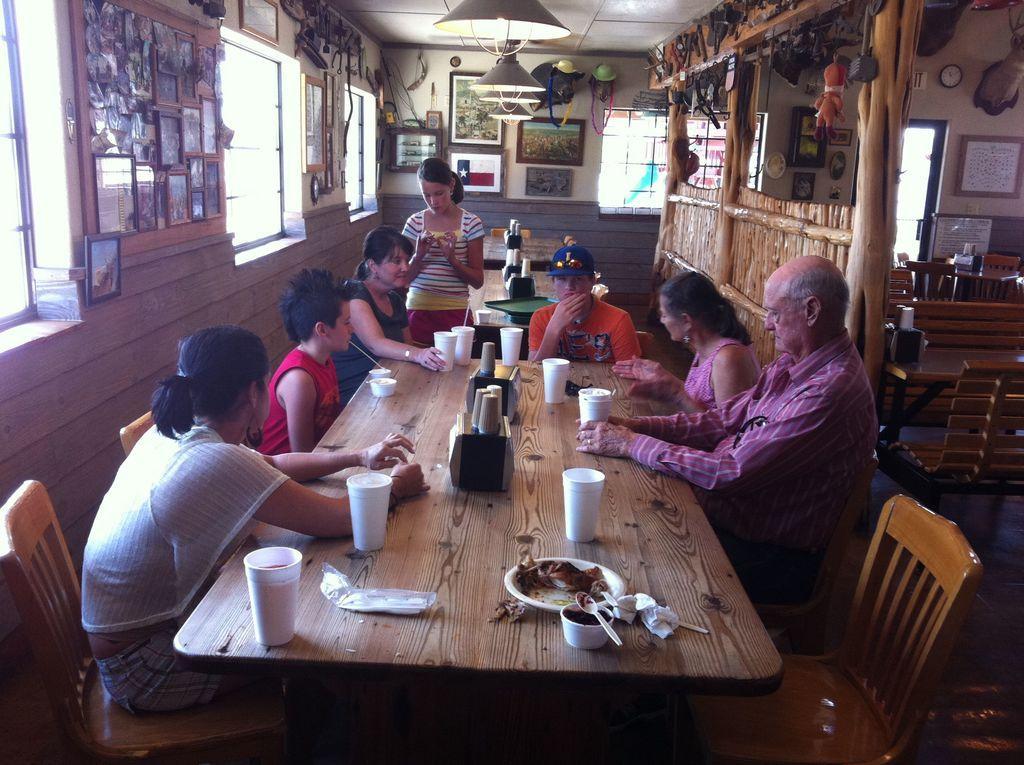Could you give a brief overview of what you see in this image? There are few people sitting around the chair in front of a table and few glasses on it behind them is a photo frames on the wall and lights hanging from the top. 